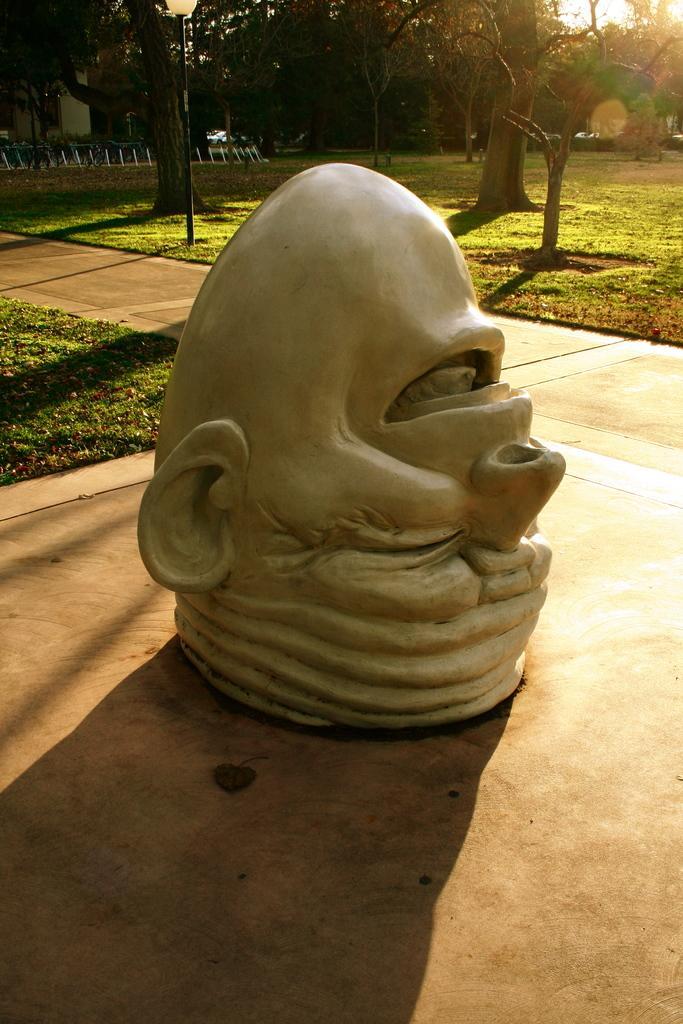In one or two sentences, can you explain what this image depicts? In the picture we can see an idol of a human head which is upside down on the plane surface path and behind it, we can see a grass surface and on it we can see some trees and far away also we can see some trees, railing and a house wall. 